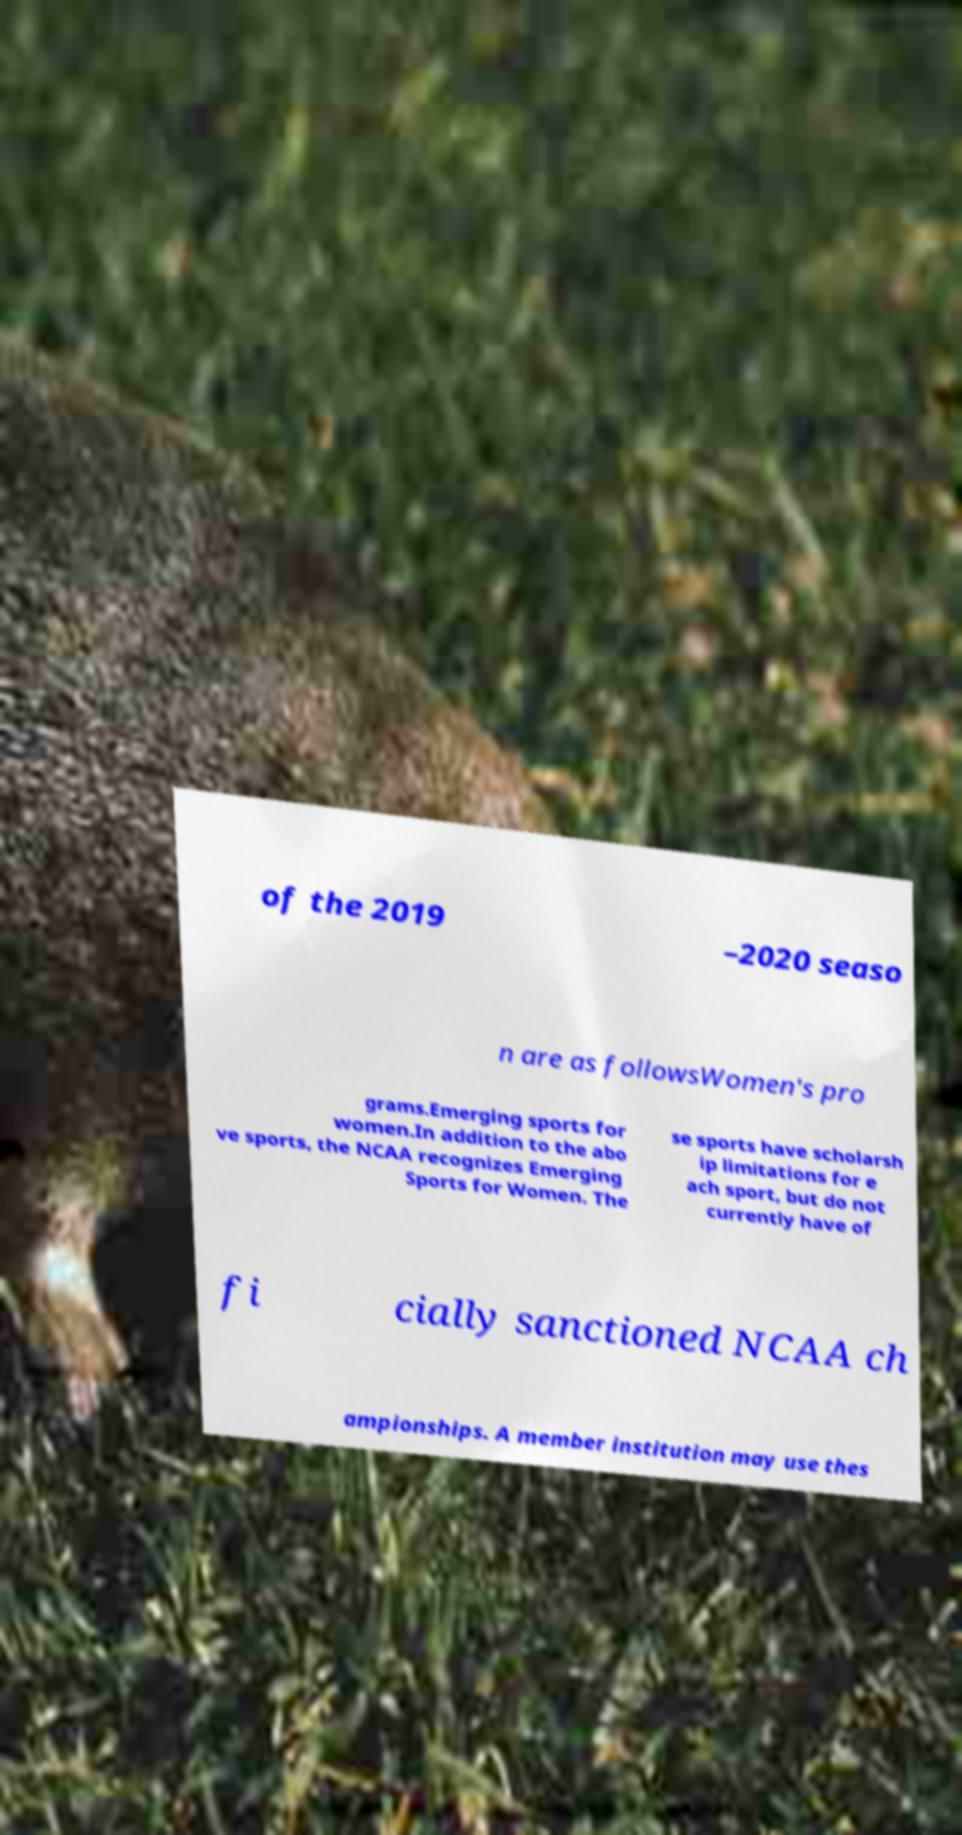Can you accurately transcribe the text from the provided image for me? of the 2019 –2020 seaso n are as followsWomen's pro grams.Emerging sports for women.In addition to the abo ve sports, the NCAA recognizes Emerging Sports for Women. The se sports have scholarsh ip limitations for e ach sport, but do not currently have of fi cially sanctioned NCAA ch ampionships. A member institution may use thes 